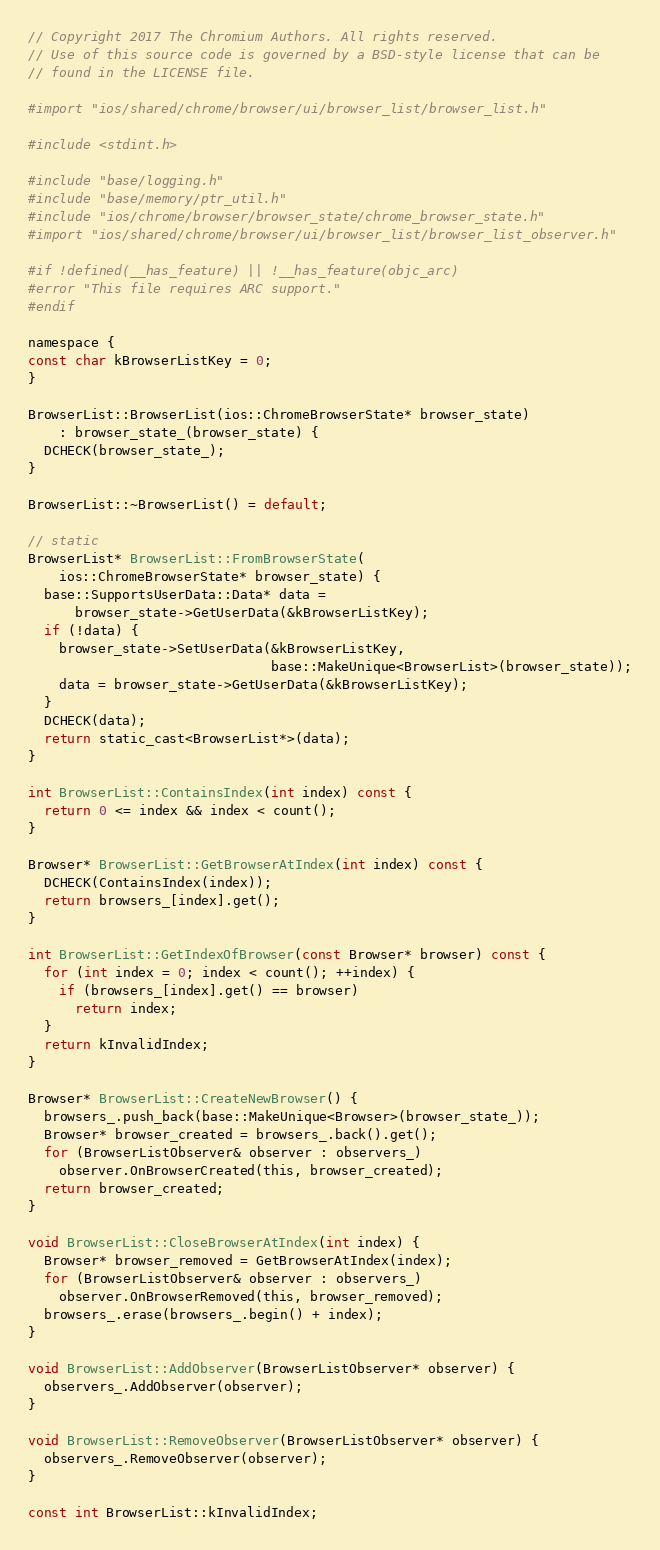Convert code to text. <code><loc_0><loc_0><loc_500><loc_500><_ObjectiveC_>// Copyright 2017 The Chromium Authors. All rights reserved.
// Use of this source code is governed by a BSD-style license that can be
// found in the LICENSE file.

#import "ios/shared/chrome/browser/ui/browser_list/browser_list.h"

#include <stdint.h>

#include "base/logging.h"
#include "base/memory/ptr_util.h"
#include "ios/chrome/browser/browser_state/chrome_browser_state.h"
#import "ios/shared/chrome/browser/ui/browser_list/browser_list_observer.h"

#if !defined(__has_feature) || !__has_feature(objc_arc)
#error "This file requires ARC support."
#endif

namespace {
const char kBrowserListKey = 0;
}

BrowserList::BrowserList(ios::ChromeBrowserState* browser_state)
    : browser_state_(browser_state) {
  DCHECK(browser_state_);
}

BrowserList::~BrowserList() = default;

// static
BrowserList* BrowserList::FromBrowserState(
    ios::ChromeBrowserState* browser_state) {
  base::SupportsUserData::Data* data =
      browser_state->GetUserData(&kBrowserListKey);
  if (!data) {
    browser_state->SetUserData(&kBrowserListKey,
                               base::MakeUnique<BrowserList>(browser_state));
    data = browser_state->GetUserData(&kBrowserListKey);
  }
  DCHECK(data);
  return static_cast<BrowserList*>(data);
}

int BrowserList::ContainsIndex(int index) const {
  return 0 <= index && index < count();
}

Browser* BrowserList::GetBrowserAtIndex(int index) const {
  DCHECK(ContainsIndex(index));
  return browsers_[index].get();
}

int BrowserList::GetIndexOfBrowser(const Browser* browser) const {
  for (int index = 0; index < count(); ++index) {
    if (browsers_[index].get() == browser)
      return index;
  }
  return kInvalidIndex;
}

Browser* BrowserList::CreateNewBrowser() {
  browsers_.push_back(base::MakeUnique<Browser>(browser_state_));
  Browser* browser_created = browsers_.back().get();
  for (BrowserListObserver& observer : observers_)
    observer.OnBrowserCreated(this, browser_created);
  return browser_created;
}

void BrowserList::CloseBrowserAtIndex(int index) {
  Browser* browser_removed = GetBrowserAtIndex(index);
  for (BrowserListObserver& observer : observers_)
    observer.OnBrowserRemoved(this, browser_removed);
  browsers_.erase(browsers_.begin() + index);
}

void BrowserList::AddObserver(BrowserListObserver* observer) {
  observers_.AddObserver(observer);
}

void BrowserList::RemoveObserver(BrowserListObserver* observer) {
  observers_.RemoveObserver(observer);
}

const int BrowserList::kInvalidIndex;
</code> 